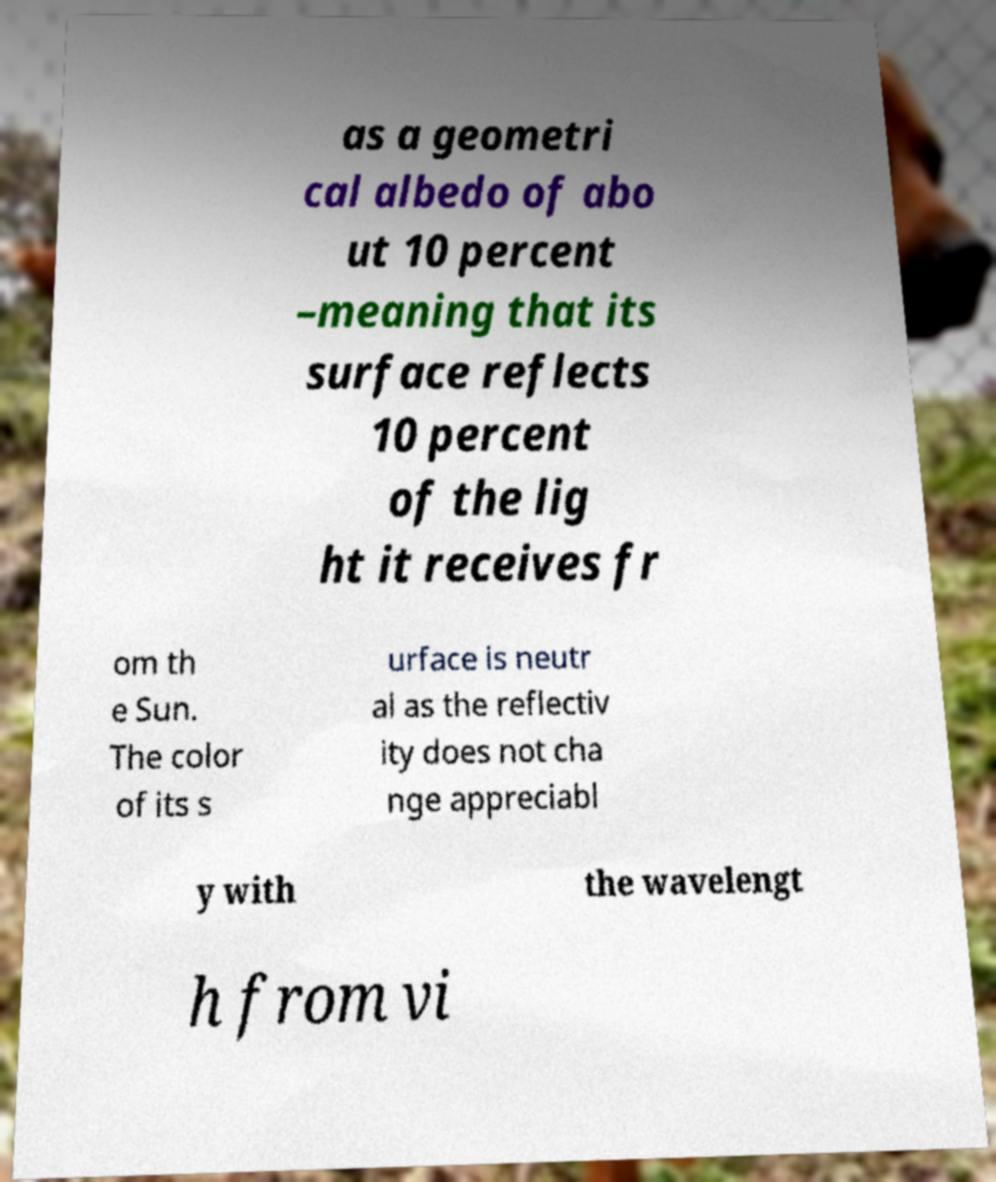Could you assist in decoding the text presented in this image and type it out clearly? as a geometri cal albedo of abo ut 10 percent –meaning that its surface reflects 10 percent of the lig ht it receives fr om th e Sun. The color of its s urface is neutr al as the reflectiv ity does not cha nge appreciabl y with the wavelengt h from vi 